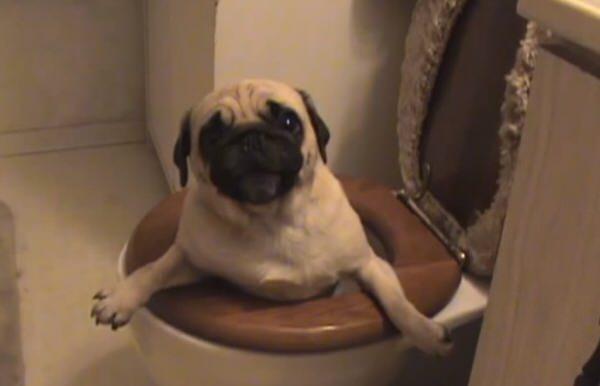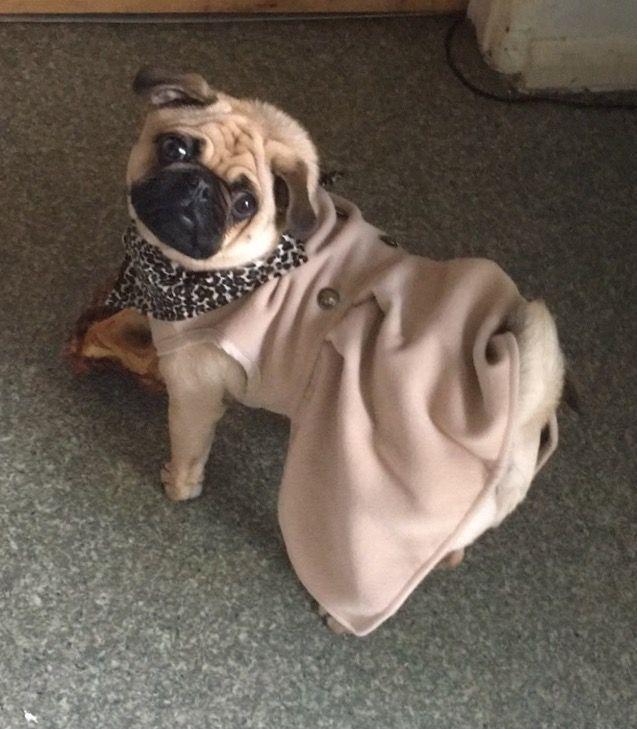The first image is the image on the left, the second image is the image on the right. Assess this claim about the two images: "Each image shows one fat beige pug in a sitting pose, and no pugs are wearing outfits.". Correct or not? Answer yes or no. No. 